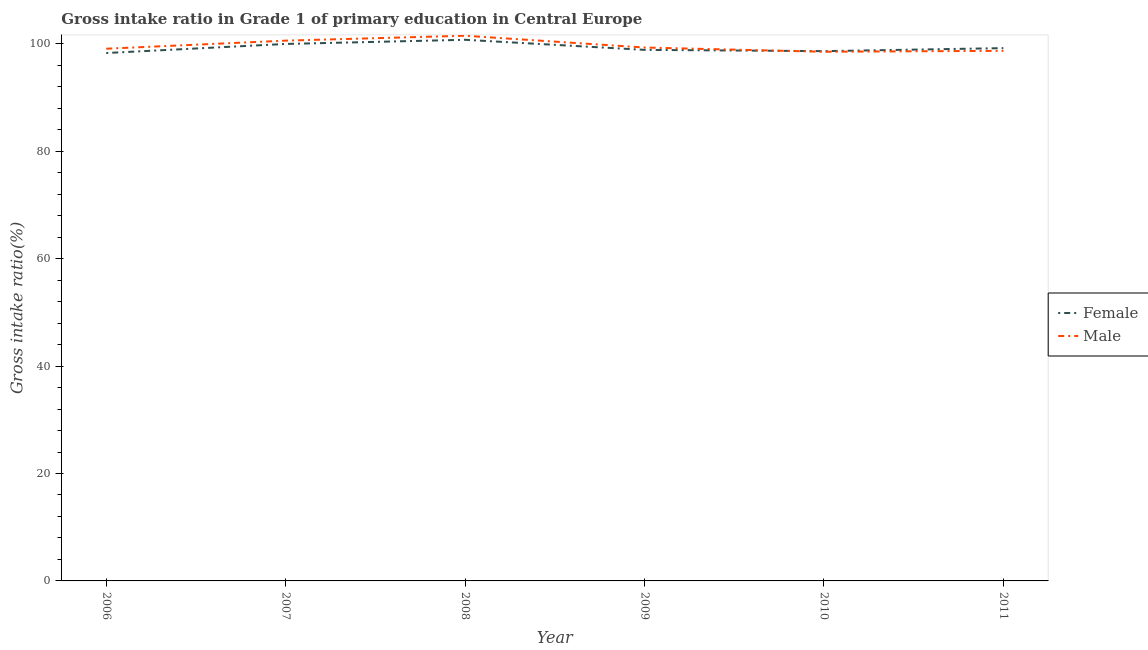How many different coloured lines are there?
Your answer should be compact. 2. Does the line corresponding to gross intake ratio(female) intersect with the line corresponding to gross intake ratio(male)?
Give a very brief answer. Yes. Is the number of lines equal to the number of legend labels?
Your answer should be compact. Yes. What is the gross intake ratio(male) in 2009?
Provide a succinct answer. 99.3. Across all years, what is the maximum gross intake ratio(female)?
Ensure brevity in your answer.  100.74. Across all years, what is the minimum gross intake ratio(female)?
Give a very brief answer. 98.28. What is the total gross intake ratio(female) in the graph?
Provide a succinct answer. 595.68. What is the difference between the gross intake ratio(female) in 2006 and that in 2008?
Provide a succinct answer. -2.46. What is the difference between the gross intake ratio(female) in 2006 and the gross intake ratio(male) in 2010?
Keep it short and to the point. -0.23. What is the average gross intake ratio(male) per year?
Ensure brevity in your answer.  99.61. In the year 2007, what is the difference between the gross intake ratio(male) and gross intake ratio(female)?
Offer a very short reply. 0.62. What is the ratio of the gross intake ratio(female) in 2009 to that in 2011?
Give a very brief answer. 1. What is the difference between the highest and the second highest gross intake ratio(female)?
Your answer should be very brief. 0.78. What is the difference between the highest and the lowest gross intake ratio(male)?
Ensure brevity in your answer.  2.98. Does the gross intake ratio(male) monotonically increase over the years?
Offer a terse response. No. How many lines are there?
Give a very brief answer. 2. How many years are there in the graph?
Keep it short and to the point. 6. Does the graph contain any zero values?
Keep it short and to the point. No. Does the graph contain grids?
Ensure brevity in your answer.  No. How many legend labels are there?
Your answer should be compact. 2. How are the legend labels stacked?
Offer a very short reply. Vertical. What is the title of the graph?
Give a very brief answer. Gross intake ratio in Grade 1 of primary education in Central Europe. What is the label or title of the X-axis?
Provide a short and direct response. Year. What is the label or title of the Y-axis?
Make the answer very short. Gross intake ratio(%). What is the Gross intake ratio(%) in Female in 2006?
Provide a short and direct response. 98.28. What is the Gross intake ratio(%) in Male in 2006?
Provide a succinct answer. 99.08. What is the Gross intake ratio(%) in Female in 2007?
Provide a succinct answer. 99.97. What is the Gross intake ratio(%) in Male in 2007?
Offer a terse response. 100.58. What is the Gross intake ratio(%) in Female in 2008?
Give a very brief answer. 100.74. What is the Gross intake ratio(%) of Male in 2008?
Your response must be concise. 101.5. What is the Gross intake ratio(%) in Female in 2009?
Offer a very short reply. 98.87. What is the Gross intake ratio(%) in Male in 2009?
Keep it short and to the point. 99.3. What is the Gross intake ratio(%) in Female in 2010?
Make the answer very short. 98.63. What is the Gross intake ratio(%) of Male in 2010?
Make the answer very short. 98.51. What is the Gross intake ratio(%) of Female in 2011?
Ensure brevity in your answer.  99.19. What is the Gross intake ratio(%) of Male in 2011?
Your response must be concise. 98.69. Across all years, what is the maximum Gross intake ratio(%) in Female?
Your answer should be compact. 100.74. Across all years, what is the maximum Gross intake ratio(%) of Male?
Offer a very short reply. 101.5. Across all years, what is the minimum Gross intake ratio(%) of Female?
Your response must be concise. 98.28. Across all years, what is the minimum Gross intake ratio(%) of Male?
Your response must be concise. 98.51. What is the total Gross intake ratio(%) of Female in the graph?
Your answer should be very brief. 595.68. What is the total Gross intake ratio(%) in Male in the graph?
Your answer should be compact. 597.67. What is the difference between the Gross intake ratio(%) in Female in 2006 and that in 2007?
Offer a very short reply. -1.69. What is the difference between the Gross intake ratio(%) in Male in 2006 and that in 2007?
Ensure brevity in your answer.  -1.5. What is the difference between the Gross intake ratio(%) of Female in 2006 and that in 2008?
Provide a short and direct response. -2.46. What is the difference between the Gross intake ratio(%) in Male in 2006 and that in 2008?
Provide a short and direct response. -2.42. What is the difference between the Gross intake ratio(%) of Female in 2006 and that in 2009?
Make the answer very short. -0.59. What is the difference between the Gross intake ratio(%) of Male in 2006 and that in 2009?
Make the answer very short. -0.22. What is the difference between the Gross intake ratio(%) of Female in 2006 and that in 2010?
Your answer should be very brief. -0.35. What is the difference between the Gross intake ratio(%) in Male in 2006 and that in 2010?
Keep it short and to the point. 0.57. What is the difference between the Gross intake ratio(%) of Female in 2006 and that in 2011?
Keep it short and to the point. -0.91. What is the difference between the Gross intake ratio(%) of Male in 2006 and that in 2011?
Ensure brevity in your answer.  0.39. What is the difference between the Gross intake ratio(%) of Female in 2007 and that in 2008?
Ensure brevity in your answer.  -0.78. What is the difference between the Gross intake ratio(%) in Male in 2007 and that in 2008?
Ensure brevity in your answer.  -0.91. What is the difference between the Gross intake ratio(%) in Female in 2007 and that in 2009?
Keep it short and to the point. 1.1. What is the difference between the Gross intake ratio(%) of Male in 2007 and that in 2009?
Your response must be concise. 1.28. What is the difference between the Gross intake ratio(%) in Female in 2007 and that in 2010?
Provide a succinct answer. 1.34. What is the difference between the Gross intake ratio(%) of Male in 2007 and that in 2010?
Provide a succinct answer. 2.07. What is the difference between the Gross intake ratio(%) of Female in 2007 and that in 2011?
Your answer should be very brief. 0.78. What is the difference between the Gross intake ratio(%) in Male in 2007 and that in 2011?
Provide a short and direct response. 1.9. What is the difference between the Gross intake ratio(%) in Female in 2008 and that in 2009?
Ensure brevity in your answer.  1.88. What is the difference between the Gross intake ratio(%) of Male in 2008 and that in 2009?
Make the answer very short. 2.19. What is the difference between the Gross intake ratio(%) in Female in 2008 and that in 2010?
Offer a very short reply. 2.11. What is the difference between the Gross intake ratio(%) of Male in 2008 and that in 2010?
Your answer should be very brief. 2.98. What is the difference between the Gross intake ratio(%) in Female in 2008 and that in 2011?
Your response must be concise. 1.55. What is the difference between the Gross intake ratio(%) of Male in 2008 and that in 2011?
Make the answer very short. 2.81. What is the difference between the Gross intake ratio(%) of Female in 2009 and that in 2010?
Your answer should be compact. 0.24. What is the difference between the Gross intake ratio(%) of Male in 2009 and that in 2010?
Your answer should be compact. 0.79. What is the difference between the Gross intake ratio(%) in Female in 2009 and that in 2011?
Your response must be concise. -0.32. What is the difference between the Gross intake ratio(%) in Male in 2009 and that in 2011?
Offer a terse response. 0.61. What is the difference between the Gross intake ratio(%) of Female in 2010 and that in 2011?
Provide a succinct answer. -0.56. What is the difference between the Gross intake ratio(%) in Male in 2010 and that in 2011?
Your response must be concise. -0.18. What is the difference between the Gross intake ratio(%) of Female in 2006 and the Gross intake ratio(%) of Male in 2007?
Make the answer very short. -2.3. What is the difference between the Gross intake ratio(%) in Female in 2006 and the Gross intake ratio(%) in Male in 2008?
Your answer should be very brief. -3.22. What is the difference between the Gross intake ratio(%) in Female in 2006 and the Gross intake ratio(%) in Male in 2009?
Offer a terse response. -1.02. What is the difference between the Gross intake ratio(%) of Female in 2006 and the Gross intake ratio(%) of Male in 2010?
Ensure brevity in your answer.  -0.23. What is the difference between the Gross intake ratio(%) of Female in 2006 and the Gross intake ratio(%) of Male in 2011?
Ensure brevity in your answer.  -0.41. What is the difference between the Gross intake ratio(%) of Female in 2007 and the Gross intake ratio(%) of Male in 2008?
Keep it short and to the point. -1.53. What is the difference between the Gross intake ratio(%) of Female in 2007 and the Gross intake ratio(%) of Male in 2009?
Ensure brevity in your answer.  0.66. What is the difference between the Gross intake ratio(%) of Female in 2007 and the Gross intake ratio(%) of Male in 2010?
Offer a very short reply. 1.45. What is the difference between the Gross intake ratio(%) of Female in 2007 and the Gross intake ratio(%) of Male in 2011?
Give a very brief answer. 1.28. What is the difference between the Gross intake ratio(%) of Female in 2008 and the Gross intake ratio(%) of Male in 2009?
Make the answer very short. 1.44. What is the difference between the Gross intake ratio(%) in Female in 2008 and the Gross intake ratio(%) in Male in 2010?
Offer a very short reply. 2.23. What is the difference between the Gross intake ratio(%) of Female in 2008 and the Gross intake ratio(%) of Male in 2011?
Keep it short and to the point. 2.05. What is the difference between the Gross intake ratio(%) of Female in 2009 and the Gross intake ratio(%) of Male in 2010?
Your answer should be compact. 0.35. What is the difference between the Gross intake ratio(%) in Female in 2009 and the Gross intake ratio(%) in Male in 2011?
Give a very brief answer. 0.18. What is the difference between the Gross intake ratio(%) of Female in 2010 and the Gross intake ratio(%) of Male in 2011?
Offer a terse response. -0.06. What is the average Gross intake ratio(%) in Female per year?
Offer a very short reply. 99.28. What is the average Gross intake ratio(%) of Male per year?
Offer a very short reply. 99.61. In the year 2007, what is the difference between the Gross intake ratio(%) in Female and Gross intake ratio(%) in Male?
Provide a succinct answer. -0.62. In the year 2008, what is the difference between the Gross intake ratio(%) of Female and Gross intake ratio(%) of Male?
Offer a very short reply. -0.75. In the year 2009, what is the difference between the Gross intake ratio(%) of Female and Gross intake ratio(%) of Male?
Provide a succinct answer. -0.44. In the year 2010, what is the difference between the Gross intake ratio(%) in Female and Gross intake ratio(%) in Male?
Your answer should be compact. 0.12. In the year 2011, what is the difference between the Gross intake ratio(%) in Female and Gross intake ratio(%) in Male?
Your answer should be very brief. 0.5. What is the ratio of the Gross intake ratio(%) of Female in 2006 to that in 2007?
Make the answer very short. 0.98. What is the ratio of the Gross intake ratio(%) of Male in 2006 to that in 2007?
Offer a very short reply. 0.98. What is the ratio of the Gross intake ratio(%) in Female in 2006 to that in 2008?
Give a very brief answer. 0.98. What is the ratio of the Gross intake ratio(%) in Male in 2006 to that in 2008?
Make the answer very short. 0.98. What is the ratio of the Gross intake ratio(%) of Male in 2006 to that in 2009?
Your answer should be compact. 1. What is the ratio of the Gross intake ratio(%) in Female in 2006 to that in 2011?
Keep it short and to the point. 0.99. What is the ratio of the Gross intake ratio(%) in Male in 2006 to that in 2011?
Make the answer very short. 1. What is the ratio of the Gross intake ratio(%) of Female in 2007 to that in 2008?
Offer a very short reply. 0.99. What is the ratio of the Gross intake ratio(%) in Female in 2007 to that in 2009?
Offer a terse response. 1.01. What is the ratio of the Gross intake ratio(%) of Male in 2007 to that in 2009?
Offer a very short reply. 1.01. What is the ratio of the Gross intake ratio(%) in Female in 2007 to that in 2010?
Provide a succinct answer. 1.01. What is the ratio of the Gross intake ratio(%) of Male in 2007 to that in 2010?
Your response must be concise. 1.02. What is the ratio of the Gross intake ratio(%) in Female in 2007 to that in 2011?
Give a very brief answer. 1.01. What is the ratio of the Gross intake ratio(%) of Male in 2007 to that in 2011?
Your response must be concise. 1.02. What is the ratio of the Gross intake ratio(%) of Male in 2008 to that in 2009?
Keep it short and to the point. 1.02. What is the ratio of the Gross intake ratio(%) of Female in 2008 to that in 2010?
Keep it short and to the point. 1.02. What is the ratio of the Gross intake ratio(%) in Male in 2008 to that in 2010?
Provide a short and direct response. 1.03. What is the ratio of the Gross intake ratio(%) of Female in 2008 to that in 2011?
Your response must be concise. 1.02. What is the ratio of the Gross intake ratio(%) in Male in 2008 to that in 2011?
Ensure brevity in your answer.  1.03. What is the ratio of the Gross intake ratio(%) of Female in 2009 to that in 2010?
Give a very brief answer. 1. What is the ratio of the Gross intake ratio(%) of Female in 2009 to that in 2011?
Provide a succinct answer. 1. What is the ratio of the Gross intake ratio(%) in Female in 2010 to that in 2011?
Your answer should be very brief. 0.99. What is the ratio of the Gross intake ratio(%) of Male in 2010 to that in 2011?
Your response must be concise. 1. What is the difference between the highest and the second highest Gross intake ratio(%) of Female?
Offer a very short reply. 0.78. What is the difference between the highest and the second highest Gross intake ratio(%) in Male?
Make the answer very short. 0.91. What is the difference between the highest and the lowest Gross intake ratio(%) of Female?
Your response must be concise. 2.46. What is the difference between the highest and the lowest Gross intake ratio(%) of Male?
Provide a short and direct response. 2.98. 